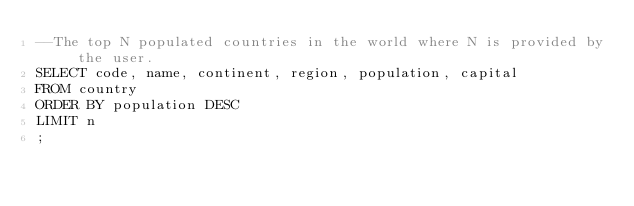<code> <loc_0><loc_0><loc_500><loc_500><_SQL_>--The top N populated countries in the world where N is provided by the user.
SELECT code, name, continent, region, population, capital
FROM country
ORDER BY population DESC
LIMIT n 
;</code> 